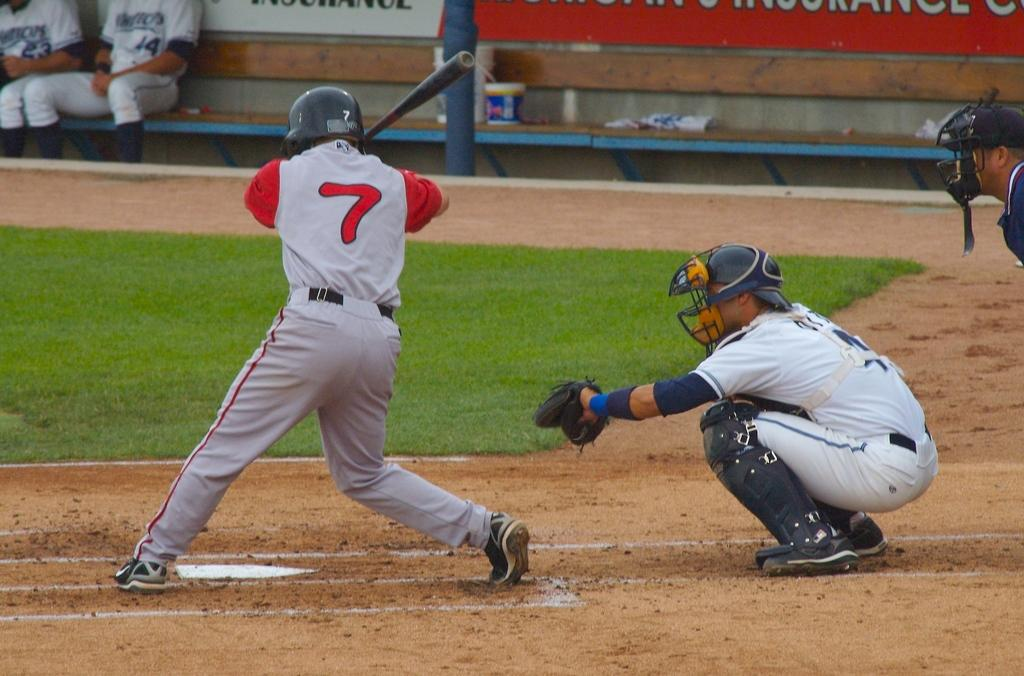<image>
Offer a succinct explanation of the picture presented. number 7 in red and gray ready to bat and catcher in white ready to catch the pitch 